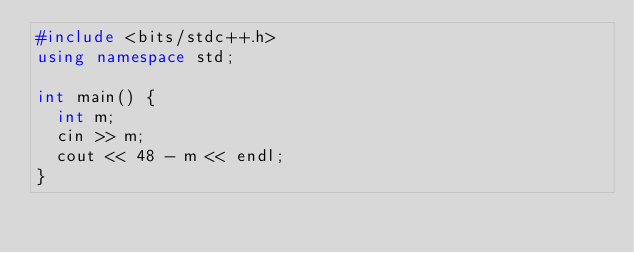<code> <loc_0><loc_0><loc_500><loc_500><_C++_>#include <bits/stdc++.h>
using namespace std;

int main() {
  int m;
  cin >> m;
  cout << 48 - m << endl;
}</code> 